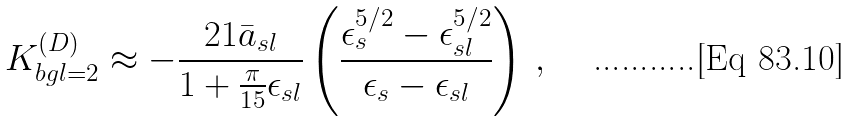<formula> <loc_0><loc_0><loc_500><loc_500>K ^ { ( D ) } _ { b g l = 2 } \approx - \frac { 2 1 \bar { a } _ { s l } } { 1 + \frac { \pi } { 1 5 } \epsilon _ { s l } } \left ( \frac { \epsilon _ { s } ^ { 5 / 2 } - \epsilon _ { s l } ^ { 5 / 2 } } { \epsilon _ { s } - \epsilon _ { s l } } \right ) \, ,</formula> 